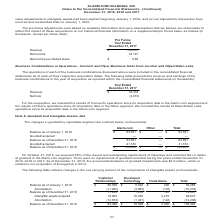According to Alarmcom Holdings's financial document, What was the amount of Amortization from Customer Relationships in 2018? According to the financial document, (11,262) (in thousands). The relevant text states: "2018 $ 88,526 $ 5,532 $ 228 $ 94,286 Amortization (11,262) (3,854) (103) (15,219) Balance as of December 31, 2018 77,264 1,678 125 79,067 Intangible assets acq..." Also, What was the total balance as of January 1, 2018? According to the financial document, $94,286 (in thousands). The relevant text states: "ce as of January 1, 2018 $ 88,526 $ 5,532 $ 228 $ 94,286 Amortization (11,262) (3,854) (103) (15,219) Balance as of December 31, 2018 77,264 1,678 125 79,06..." Also, What were the total Intangible assets acquired? According to the financial document, 38,607 (in thousands). The relevant text states: "67 Intangible assets acquired 19,805 16,583 2,219 38,607 Amortization (12,673) (1,441) (122) (14,236) Balance as of December 31, 2019 $ 84,396 $ 16,820 $ 2,..." Also, can you calculate: What was the change in the total balance between December 31, 2019 and December 31, 2018? Based on the calculation: 103,438-79,067, the result is 24371 (in thousands). This is based on the information: "Balance as of December 31, 2018 77,264 1,678 125 79,067 Intangible assets acquired 19,805 16,583 2,219 38,607 Amortization (12,673) (1,441) (122) (14,236) of December 31, 2019 $ 84,396 $ 16,820 $ 2,22..." The key data points involved are: 103,438, 79,067. Also, How many components of intangible assets had a total that exceeded $50,000 thousand as of December 31, 2019? Based on the analysis, there are 1 instances. The counting process: Customer Relationships. Also, can you calculate: What was the percentage change in the total balance between January 1, 2018 and December 31, 2018?  To answer this question, I need to perform calculations using the financial data. The calculation is: (79,067-94,286)/94,286, which equals -16.14 (percentage). This is based on the information: "ce as of January 1, 2018 $ 88,526 $ 5,532 $ 228 $ 94,286 Amortization (11,262) (3,854) (103) (15,219) Balance as of December 31, 2018 77,264 1,678 125 79,06 Balance as of December 31, 2018 77,264 1,67..." The key data points involved are: 79,067, 94,286. 